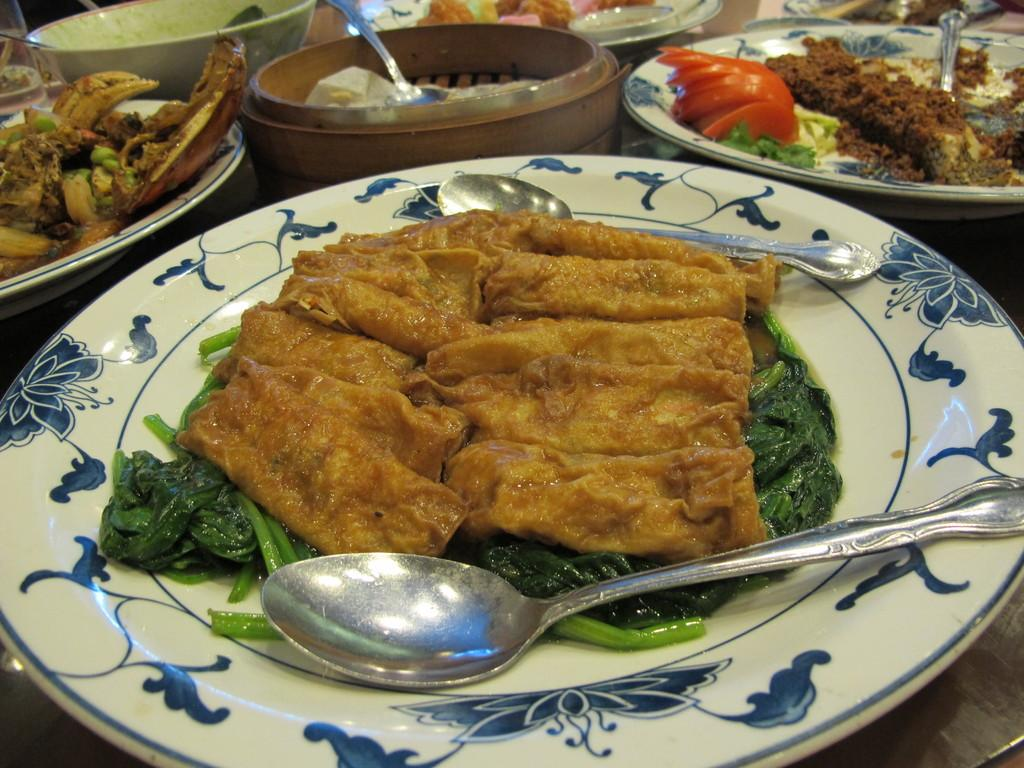What types of food can be seen in the image? There are food items in plates and bowls in the image. What colors are present in the food? The food has colors such as brown, green, red, and white. What utensils are visible in the image? Spoons are visible in the image. Where are the spoons located? The spoons are on a surface. How does the creator of the food items react to the earthquake in the image? There is no earthquake or creator of the food items present in the image. What type of bead is used to decorate the food in the image? There are no beads present in the image; it features food items in plates and bowls with spoons on a surface. 